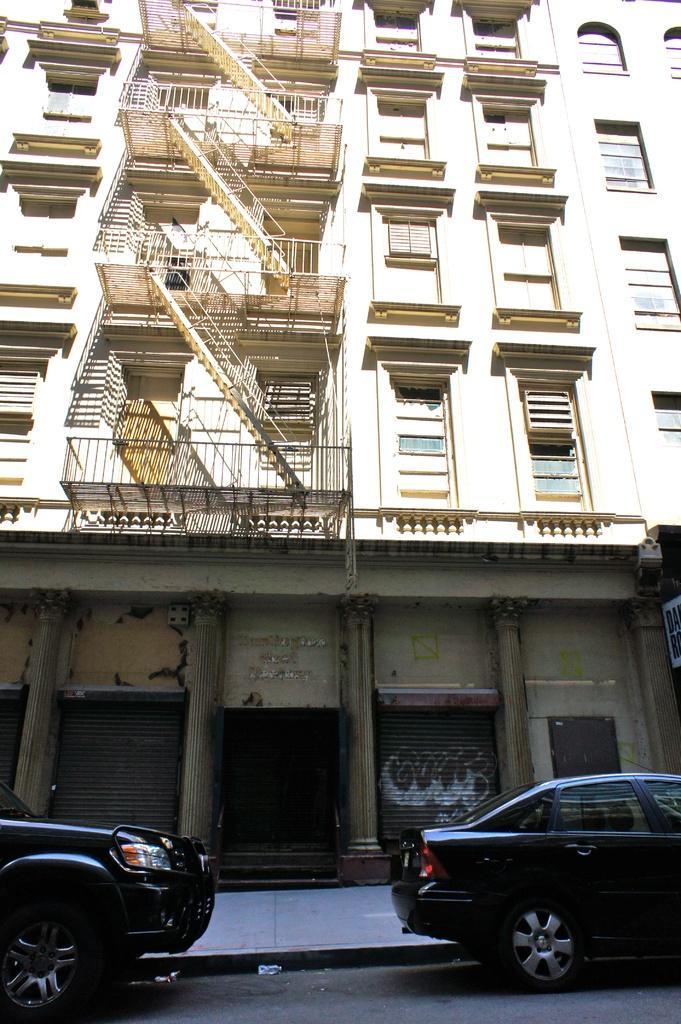Describe this image in one or two sentences. In the center of the image, we can see a building and there are railings. At the bottom, there are vehicles on the road. 